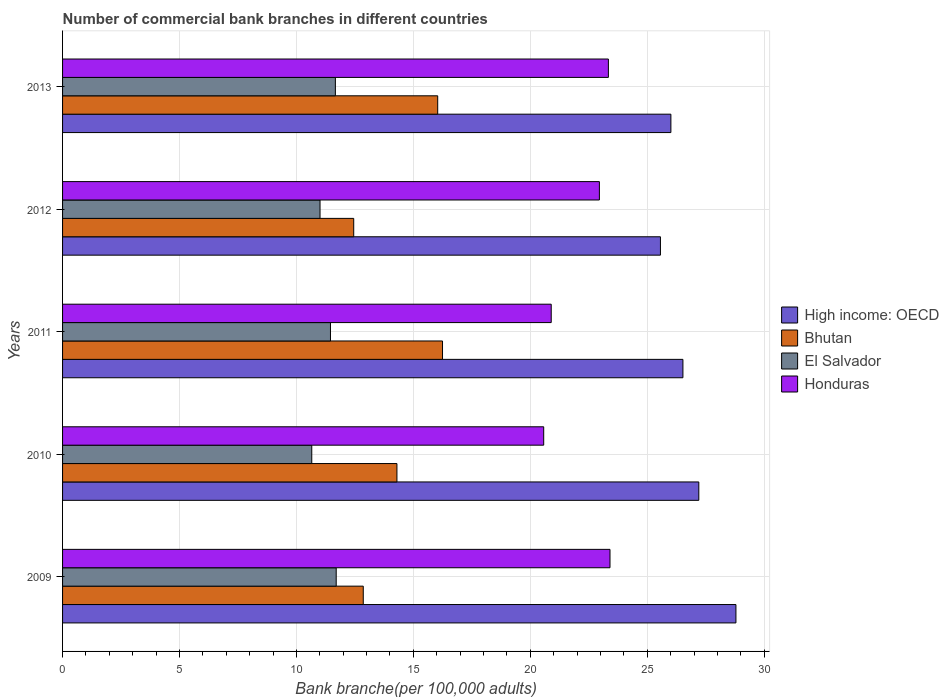How many groups of bars are there?
Your answer should be compact. 5. Are the number of bars on each tick of the Y-axis equal?
Keep it short and to the point. Yes. How many bars are there on the 1st tick from the bottom?
Give a very brief answer. 4. What is the number of commercial bank branches in Honduras in 2009?
Provide a short and direct response. 23.41. Across all years, what is the maximum number of commercial bank branches in Honduras?
Give a very brief answer. 23.41. Across all years, what is the minimum number of commercial bank branches in El Salvador?
Provide a short and direct response. 10.66. In which year was the number of commercial bank branches in El Salvador maximum?
Keep it short and to the point. 2009. In which year was the number of commercial bank branches in Bhutan minimum?
Provide a succinct answer. 2012. What is the total number of commercial bank branches in Honduras in the graph?
Provide a succinct answer. 111.17. What is the difference between the number of commercial bank branches in Bhutan in 2009 and that in 2013?
Give a very brief answer. -3.18. What is the difference between the number of commercial bank branches in El Salvador in 2010 and the number of commercial bank branches in Bhutan in 2009?
Give a very brief answer. -2.2. What is the average number of commercial bank branches in Honduras per year?
Ensure brevity in your answer.  22.23. In the year 2010, what is the difference between the number of commercial bank branches in Honduras and number of commercial bank branches in High income: OECD?
Ensure brevity in your answer.  -6.63. What is the ratio of the number of commercial bank branches in High income: OECD in 2009 to that in 2012?
Your answer should be compact. 1.13. Is the difference between the number of commercial bank branches in Honduras in 2010 and 2011 greater than the difference between the number of commercial bank branches in High income: OECD in 2010 and 2011?
Your answer should be compact. No. What is the difference between the highest and the second highest number of commercial bank branches in Honduras?
Give a very brief answer. 0.07. What is the difference between the highest and the lowest number of commercial bank branches in High income: OECD?
Make the answer very short. 3.23. In how many years, is the number of commercial bank branches in High income: OECD greater than the average number of commercial bank branches in High income: OECD taken over all years?
Ensure brevity in your answer.  2. Is it the case that in every year, the sum of the number of commercial bank branches in High income: OECD and number of commercial bank branches in Honduras is greater than the sum of number of commercial bank branches in Bhutan and number of commercial bank branches in El Salvador?
Make the answer very short. No. What does the 4th bar from the top in 2013 represents?
Offer a terse response. High income: OECD. What does the 4th bar from the bottom in 2010 represents?
Make the answer very short. Honduras. Is it the case that in every year, the sum of the number of commercial bank branches in Bhutan and number of commercial bank branches in Honduras is greater than the number of commercial bank branches in High income: OECD?
Offer a very short reply. Yes. How many bars are there?
Make the answer very short. 20. Are all the bars in the graph horizontal?
Offer a terse response. Yes. How many years are there in the graph?
Give a very brief answer. 5. What is the difference between two consecutive major ticks on the X-axis?
Ensure brevity in your answer.  5. Does the graph contain grids?
Keep it short and to the point. Yes. How many legend labels are there?
Your answer should be very brief. 4. What is the title of the graph?
Provide a short and direct response. Number of commercial bank branches in different countries. What is the label or title of the X-axis?
Your answer should be very brief. Bank branche(per 100,0 adults). What is the label or title of the Y-axis?
Your answer should be compact. Years. What is the Bank branche(per 100,000 adults) of High income: OECD in 2009?
Provide a succinct answer. 28.79. What is the Bank branche(per 100,000 adults) of Bhutan in 2009?
Provide a short and direct response. 12.86. What is the Bank branche(per 100,000 adults) of El Salvador in 2009?
Make the answer very short. 11.7. What is the Bank branche(per 100,000 adults) in Honduras in 2009?
Your response must be concise. 23.41. What is the Bank branche(per 100,000 adults) in High income: OECD in 2010?
Offer a terse response. 27.21. What is the Bank branche(per 100,000 adults) of Bhutan in 2010?
Your answer should be compact. 14.3. What is the Bank branche(per 100,000 adults) of El Salvador in 2010?
Offer a very short reply. 10.66. What is the Bank branche(per 100,000 adults) of Honduras in 2010?
Offer a very short reply. 20.57. What is the Bank branche(per 100,000 adults) in High income: OECD in 2011?
Your answer should be very brief. 26.53. What is the Bank branche(per 100,000 adults) of Bhutan in 2011?
Ensure brevity in your answer.  16.25. What is the Bank branche(per 100,000 adults) in El Salvador in 2011?
Provide a short and direct response. 11.46. What is the Bank branche(per 100,000 adults) in Honduras in 2011?
Provide a short and direct response. 20.89. What is the Bank branche(per 100,000 adults) in High income: OECD in 2012?
Provide a succinct answer. 25.56. What is the Bank branche(per 100,000 adults) of Bhutan in 2012?
Offer a terse response. 12.45. What is the Bank branche(per 100,000 adults) of El Salvador in 2012?
Offer a terse response. 11.01. What is the Bank branche(per 100,000 adults) in Honduras in 2012?
Provide a short and direct response. 22.95. What is the Bank branche(per 100,000 adults) in High income: OECD in 2013?
Offer a terse response. 26.01. What is the Bank branche(per 100,000 adults) in Bhutan in 2013?
Your answer should be very brief. 16.04. What is the Bank branche(per 100,000 adults) in El Salvador in 2013?
Give a very brief answer. 11.67. What is the Bank branche(per 100,000 adults) of Honduras in 2013?
Your answer should be very brief. 23.34. Across all years, what is the maximum Bank branche(per 100,000 adults) in High income: OECD?
Your answer should be compact. 28.79. Across all years, what is the maximum Bank branche(per 100,000 adults) in Bhutan?
Ensure brevity in your answer.  16.25. Across all years, what is the maximum Bank branche(per 100,000 adults) of El Salvador?
Keep it short and to the point. 11.7. Across all years, what is the maximum Bank branche(per 100,000 adults) of Honduras?
Ensure brevity in your answer.  23.41. Across all years, what is the minimum Bank branche(per 100,000 adults) of High income: OECD?
Keep it short and to the point. 25.56. Across all years, what is the minimum Bank branche(per 100,000 adults) in Bhutan?
Keep it short and to the point. 12.45. Across all years, what is the minimum Bank branche(per 100,000 adults) of El Salvador?
Provide a succinct answer. 10.66. Across all years, what is the minimum Bank branche(per 100,000 adults) in Honduras?
Offer a terse response. 20.57. What is the total Bank branche(per 100,000 adults) in High income: OECD in the graph?
Provide a succinct answer. 134.1. What is the total Bank branche(per 100,000 adults) of Bhutan in the graph?
Offer a terse response. 71.89. What is the total Bank branche(per 100,000 adults) in El Salvador in the graph?
Offer a very short reply. 56.49. What is the total Bank branche(per 100,000 adults) in Honduras in the graph?
Your answer should be compact. 111.17. What is the difference between the Bank branche(per 100,000 adults) of High income: OECD in 2009 and that in 2010?
Offer a terse response. 1.59. What is the difference between the Bank branche(per 100,000 adults) in Bhutan in 2009 and that in 2010?
Your response must be concise. -1.44. What is the difference between the Bank branche(per 100,000 adults) in El Salvador in 2009 and that in 2010?
Give a very brief answer. 1.04. What is the difference between the Bank branche(per 100,000 adults) of Honduras in 2009 and that in 2010?
Make the answer very short. 2.83. What is the difference between the Bank branche(per 100,000 adults) of High income: OECD in 2009 and that in 2011?
Provide a succinct answer. 2.27. What is the difference between the Bank branche(per 100,000 adults) of Bhutan in 2009 and that in 2011?
Offer a very short reply. -3.39. What is the difference between the Bank branche(per 100,000 adults) in El Salvador in 2009 and that in 2011?
Ensure brevity in your answer.  0.25. What is the difference between the Bank branche(per 100,000 adults) in Honduras in 2009 and that in 2011?
Offer a very short reply. 2.51. What is the difference between the Bank branche(per 100,000 adults) in High income: OECD in 2009 and that in 2012?
Keep it short and to the point. 3.23. What is the difference between the Bank branche(per 100,000 adults) in Bhutan in 2009 and that in 2012?
Keep it short and to the point. 0.41. What is the difference between the Bank branche(per 100,000 adults) of El Salvador in 2009 and that in 2012?
Offer a terse response. 0.69. What is the difference between the Bank branche(per 100,000 adults) of Honduras in 2009 and that in 2012?
Provide a succinct answer. 0.45. What is the difference between the Bank branche(per 100,000 adults) of High income: OECD in 2009 and that in 2013?
Offer a very short reply. 2.78. What is the difference between the Bank branche(per 100,000 adults) in Bhutan in 2009 and that in 2013?
Your answer should be very brief. -3.18. What is the difference between the Bank branche(per 100,000 adults) of El Salvador in 2009 and that in 2013?
Provide a succinct answer. 0.04. What is the difference between the Bank branche(per 100,000 adults) of Honduras in 2009 and that in 2013?
Your answer should be very brief. 0.07. What is the difference between the Bank branche(per 100,000 adults) in High income: OECD in 2010 and that in 2011?
Offer a very short reply. 0.68. What is the difference between the Bank branche(per 100,000 adults) in Bhutan in 2010 and that in 2011?
Provide a short and direct response. -1.95. What is the difference between the Bank branche(per 100,000 adults) in El Salvador in 2010 and that in 2011?
Give a very brief answer. -0.8. What is the difference between the Bank branche(per 100,000 adults) of Honduras in 2010 and that in 2011?
Your answer should be very brief. -0.32. What is the difference between the Bank branche(per 100,000 adults) in High income: OECD in 2010 and that in 2012?
Offer a terse response. 1.64. What is the difference between the Bank branche(per 100,000 adults) of Bhutan in 2010 and that in 2012?
Provide a short and direct response. 1.85. What is the difference between the Bank branche(per 100,000 adults) in El Salvador in 2010 and that in 2012?
Ensure brevity in your answer.  -0.35. What is the difference between the Bank branche(per 100,000 adults) in Honduras in 2010 and that in 2012?
Your response must be concise. -2.38. What is the difference between the Bank branche(per 100,000 adults) in High income: OECD in 2010 and that in 2013?
Give a very brief answer. 1.19. What is the difference between the Bank branche(per 100,000 adults) in Bhutan in 2010 and that in 2013?
Offer a very short reply. -1.74. What is the difference between the Bank branche(per 100,000 adults) in El Salvador in 2010 and that in 2013?
Give a very brief answer. -1.01. What is the difference between the Bank branche(per 100,000 adults) in Honduras in 2010 and that in 2013?
Your response must be concise. -2.77. What is the difference between the Bank branche(per 100,000 adults) in High income: OECD in 2011 and that in 2012?
Make the answer very short. 0.96. What is the difference between the Bank branche(per 100,000 adults) in Bhutan in 2011 and that in 2012?
Your answer should be compact. 3.8. What is the difference between the Bank branche(per 100,000 adults) of El Salvador in 2011 and that in 2012?
Your answer should be very brief. 0.45. What is the difference between the Bank branche(per 100,000 adults) in Honduras in 2011 and that in 2012?
Keep it short and to the point. -2.06. What is the difference between the Bank branche(per 100,000 adults) in High income: OECD in 2011 and that in 2013?
Ensure brevity in your answer.  0.51. What is the difference between the Bank branche(per 100,000 adults) in Bhutan in 2011 and that in 2013?
Ensure brevity in your answer.  0.21. What is the difference between the Bank branche(per 100,000 adults) of El Salvador in 2011 and that in 2013?
Offer a terse response. -0.21. What is the difference between the Bank branche(per 100,000 adults) of Honduras in 2011 and that in 2013?
Your response must be concise. -2.44. What is the difference between the Bank branche(per 100,000 adults) in High income: OECD in 2012 and that in 2013?
Offer a terse response. -0.45. What is the difference between the Bank branche(per 100,000 adults) of Bhutan in 2012 and that in 2013?
Ensure brevity in your answer.  -3.59. What is the difference between the Bank branche(per 100,000 adults) of El Salvador in 2012 and that in 2013?
Make the answer very short. -0.66. What is the difference between the Bank branche(per 100,000 adults) of Honduras in 2012 and that in 2013?
Make the answer very short. -0.38. What is the difference between the Bank branche(per 100,000 adults) of High income: OECD in 2009 and the Bank branche(per 100,000 adults) of Bhutan in 2010?
Keep it short and to the point. 14.49. What is the difference between the Bank branche(per 100,000 adults) in High income: OECD in 2009 and the Bank branche(per 100,000 adults) in El Salvador in 2010?
Your response must be concise. 18.14. What is the difference between the Bank branche(per 100,000 adults) in High income: OECD in 2009 and the Bank branche(per 100,000 adults) in Honduras in 2010?
Provide a short and direct response. 8.22. What is the difference between the Bank branche(per 100,000 adults) in Bhutan in 2009 and the Bank branche(per 100,000 adults) in El Salvador in 2010?
Provide a succinct answer. 2.2. What is the difference between the Bank branche(per 100,000 adults) in Bhutan in 2009 and the Bank branche(per 100,000 adults) in Honduras in 2010?
Give a very brief answer. -7.72. What is the difference between the Bank branche(per 100,000 adults) of El Salvador in 2009 and the Bank branche(per 100,000 adults) of Honduras in 2010?
Offer a very short reply. -8.87. What is the difference between the Bank branche(per 100,000 adults) of High income: OECD in 2009 and the Bank branche(per 100,000 adults) of Bhutan in 2011?
Make the answer very short. 12.55. What is the difference between the Bank branche(per 100,000 adults) of High income: OECD in 2009 and the Bank branche(per 100,000 adults) of El Salvador in 2011?
Give a very brief answer. 17.34. What is the difference between the Bank branche(per 100,000 adults) in High income: OECD in 2009 and the Bank branche(per 100,000 adults) in Honduras in 2011?
Your answer should be very brief. 7.9. What is the difference between the Bank branche(per 100,000 adults) in Bhutan in 2009 and the Bank branche(per 100,000 adults) in El Salvador in 2011?
Your response must be concise. 1.4. What is the difference between the Bank branche(per 100,000 adults) in Bhutan in 2009 and the Bank branche(per 100,000 adults) in Honduras in 2011?
Your answer should be compact. -8.04. What is the difference between the Bank branche(per 100,000 adults) in El Salvador in 2009 and the Bank branche(per 100,000 adults) in Honduras in 2011?
Offer a terse response. -9.19. What is the difference between the Bank branche(per 100,000 adults) in High income: OECD in 2009 and the Bank branche(per 100,000 adults) in Bhutan in 2012?
Your answer should be very brief. 16.34. What is the difference between the Bank branche(per 100,000 adults) in High income: OECD in 2009 and the Bank branche(per 100,000 adults) in El Salvador in 2012?
Keep it short and to the point. 17.78. What is the difference between the Bank branche(per 100,000 adults) of High income: OECD in 2009 and the Bank branche(per 100,000 adults) of Honduras in 2012?
Give a very brief answer. 5.84. What is the difference between the Bank branche(per 100,000 adults) of Bhutan in 2009 and the Bank branche(per 100,000 adults) of El Salvador in 2012?
Your answer should be compact. 1.85. What is the difference between the Bank branche(per 100,000 adults) of Bhutan in 2009 and the Bank branche(per 100,000 adults) of Honduras in 2012?
Provide a short and direct response. -10.1. What is the difference between the Bank branche(per 100,000 adults) of El Salvador in 2009 and the Bank branche(per 100,000 adults) of Honduras in 2012?
Provide a short and direct response. -11.25. What is the difference between the Bank branche(per 100,000 adults) of High income: OECD in 2009 and the Bank branche(per 100,000 adults) of Bhutan in 2013?
Your answer should be very brief. 12.75. What is the difference between the Bank branche(per 100,000 adults) of High income: OECD in 2009 and the Bank branche(per 100,000 adults) of El Salvador in 2013?
Your answer should be very brief. 17.13. What is the difference between the Bank branche(per 100,000 adults) of High income: OECD in 2009 and the Bank branche(per 100,000 adults) of Honduras in 2013?
Keep it short and to the point. 5.45. What is the difference between the Bank branche(per 100,000 adults) of Bhutan in 2009 and the Bank branche(per 100,000 adults) of El Salvador in 2013?
Your answer should be compact. 1.19. What is the difference between the Bank branche(per 100,000 adults) in Bhutan in 2009 and the Bank branche(per 100,000 adults) in Honduras in 2013?
Offer a terse response. -10.48. What is the difference between the Bank branche(per 100,000 adults) in El Salvador in 2009 and the Bank branche(per 100,000 adults) in Honduras in 2013?
Ensure brevity in your answer.  -11.64. What is the difference between the Bank branche(per 100,000 adults) in High income: OECD in 2010 and the Bank branche(per 100,000 adults) in Bhutan in 2011?
Make the answer very short. 10.96. What is the difference between the Bank branche(per 100,000 adults) of High income: OECD in 2010 and the Bank branche(per 100,000 adults) of El Salvador in 2011?
Give a very brief answer. 15.75. What is the difference between the Bank branche(per 100,000 adults) in High income: OECD in 2010 and the Bank branche(per 100,000 adults) in Honduras in 2011?
Provide a short and direct response. 6.31. What is the difference between the Bank branche(per 100,000 adults) of Bhutan in 2010 and the Bank branche(per 100,000 adults) of El Salvador in 2011?
Your response must be concise. 2.84. What is the difference between the Bank branche(per 100,000 adults) in Bhutan in 2010 and the Bank branche(per 100,000 adults) in Honduras in 2011?
Ensure brevity in your answer.  -6.6. What is the difference between the Bank branche(per 100,000 adults) of El Salvador in 2010 and the Bank branche(per 100,000 adults) of Honduras in 2011?
Give a very brief answer. -10.24. What is the difference between the Bank branche(per 100,000 adults) in High income: OECD in 2010 and the Bank branche(per 100,000 adults) in Bhutan in 2012?
Your answer should be very brief. 14.76. What is the difference between the Bank branche(per 100,000 adults) of High income: OECD in 2010 and the Bank branche(per 100,000 adults) of El Salvador in 2012?
Offer a very short reply. 16.2. What is the difference between the Bank branche(per 100,000 adults) in High income: OECD in 2010 and the Bank branche(per 100,000 adults) in Honduras in 2012?
Ensure brevity in your answer.  4.25. What is the difference between the Bank branche(per 100,000 adults) in Bhutan in 2010 and the Bank branche(per 100,000 adults) in El Salvador in 2012?
Your answer should be very brief. 3.29. What is the difference between the Bank branche(per 100,000 adults) of Bhutan in 2010 and the Bank branche(per 100,000 adults) of Honduras in 2012?
Make the answer very short. -8.66. What is the difference between the Bank branche(per 100,000 adults) in El Salvador in 2010 and the Bank branche(per 100,000 adults) in Honduras in 2012?
Provide a succinct answer. -12.3. What is the difference between the Bank branche(per 100,000 adults) of High income: OECD in 2010 and the Bank branche(per 100,000 adults) of Bhutan in 2013?
Offer a terse response. 11.16. What is the difference between the Bank branche(per 100,000 adults) in High income: OECD in 2010 and the Bank branche(per 100,000 adults) in El Salvador in 2013?
Offer a terse response. 15.54. What is the difference between the Bank branche(per 100,000 adults) of High income: OECD in 2010 and the Bank branche(per 100,000 adults) of Honduras in 2013?
Make the answer very short. 3.87. What is the difference between the Bank branche(per 100,000 adults) in Bhutan in 2010 and the Bank branche(per 100,000 adults) in El Salvador in 2013?
Keep it short and to the point. 2.63. What is the difference between the Bank branche(per 100,000 adults) of Bhutan in 2010 and the Bank branche(per 100,000 adults) of Honduras in 2013?
Ensure brevity in your answer.  -9.04. What is the difference between the Bank branche(per 100,000 adults) of El Salvador in 2010 and the Bank branche(per 100,000 adults) of Honduras in 2013?
Keep it short and to the point. -12.68. What is the difference between the Bank branche(per 100,000 adults) of High income: OECD in 2011 and the Bank branche(per 100,000 adults) of Bhutan in 2012?
Keep it short and to the point. 14.08. What is the difference between the Bank branche(per 100,000 adults) in High income: OECD in 2011 and the Bank branche(per 100,000 adults) in El Salvador in 2012?
Give a very brief answer. 15.52. What is the difference between the Bank branche(per 100,000 adults) in High income: OECD in 2011 and the Bank branche(per 100,000 adults) in Honduras in 2012?
Provide a short and direct response. 3.57. What is the difference between the Bank branche(per 100,000 adults) in Bhutan in 2011 and the Bank branche(per 100,000 adults) in El Salvador in 2012?
Keep it short and to the point. 5.24. What is the difference between the Bank branche(per 100,000 adults) of Bhutan in 2011 and the Bank branche(per 100,000 adults) of Honduras in 2012?
Offer a very short reply. -6.71. What is the difference between the Bank branche(per 100,000 adults) in El Salvador in 2011 and the Bank branche(per 100,000 adults) in Honduras in 2012?
Your response must be concise. -11.5. What is the difference between the Bank branche(per 100,000 adults) of High income: OECD in 2011 and the Bank branche(per 100,000 adults) of Bhutan in 2013?
Offer a very short reply. 10.49. What is the difference between the Bank branche(per 100,000 adults) in High income: OECD in 2011 and the Bank branche(per 100,000 adults) in El Salvador in 2013?
Your response must be concise. 14.86. What is the difference between the Bank branche(per 100,000 adults) of High income: OECD in 2011 and the Bank branche(per 100,000 adults) of Honduras in 2013?
Make the answer very short. 3.19. What is the difference between the Bank branche(per 100,000 adults) of Bhutan in 2011 and the Bank branche(per 100,000 adults) of El Salvador in 2013?
Keep it short and to the point. 4.58. What is the difference between the Bank branche(per 100,000 adults) of Bhutan in 2011 and the Bank branche(per 100,000 adults) of Honduras in 2013?
Your answer should be compact. -7.09. What is the difference between the Bank branche(per 100,000 adults) in El Salvador in 2011 and the Bank branche(per 100,000 adults) in Honduras in 2013?
Offer a very short reply. -11.88. What is the difference between the Bank branche(per 100,000 adults) of High income: OECD in 2012 and the Bank branche(per 100,000 adults) of Bhutan in 2013?
Your response must be concise. 9.52. What is the difference between the Bank branche(per 100,000 adults) of High income: OECD in 2012 and the Bank branche(per 100,000 adults) of El Salvador in 2013?
Provide a succinct answer. 13.9. What is the difference between the Bank branche(per 100,000 adults) of High income: OECD in 2012 and the Bank branche(per 100,000 adults) of Honduras in 2013?
Ensure brevity in your answer.  2.23. What is the difference between the Bank branche(per 100,000 adults) in Bhutan in 2012 and the Bank branche(per 100,000 adults) in El Salvador in 2013?
Offer a terse response. 0.78. What is the difference between the Bank branche(per 100,000 adults) of Bhutan in 2012 and the Bank branche(per 100,000 adults) of Honduras in 2013?
Offer a very short reply. -10.89. What is the difference between the Bank branche(per 100,000 adults) of El Salvador in 2012 and the Bank branche(per 100,000 adults) of Honduras in 2013?
Give a very brief answer. -12.33. What is the average Bank branche(per 100,000 adults) of High income: OECD per year?
Keep it short and to the point. 26.82. What is the average Bank branche(per 100,000 adults) in Bhutan per year?
Make the answer very short. 14.38. What is the average Bank branche(per 100,000 adults) in El Salvador per year?
Your answer should be compact. 11.3. What is the average Bank branche(per 100,000 adults) in Honduras per year?
Your response must be concise. 22.23. In the year 2009, what is the difference between the Bank branche(per 100,000 adults) of High income: OECD and Bank branche(per 100,000 adults) of Bhutan?
Provide a succinct answer. 15.94. In the year 2009, what is the difference between the Bank branche(per 100,000 adults) of High income: OECD and Bank branche(per 100,000 adults) of El Salvador?
Ensure brevity in your answer.  17.09. In the year 2009, what is the difference between the Bank branche(per 100,000 adults) in High income: OECD and Bank branche(per 100,000 adults) in Honduras?
Offer a very short reply. 5.38. In the year 2009, what is the difference between the Bank branche(per 100,000 adults) in Bhutan and Bank branche(per 100,000 adults) in El Salvador?
Give a very brief answer. 1.16. In the year 2009, what is the difference between the Bank branche(per 100,000 adults) of Bhutan and Bank branche(per 100,000 adults) of Honduras?
Your response must be concise. -10.55. In the year 2009, what is the difference between the Bank branche(per 100,000 adults) in El Salvador and Bank branche(per 100,000 adults) in Honduras?
Keep it short and to the point. -11.71. In the year 2010, what is the difference between the Bank branche(per 100,000 adults) in High income: OECD and Bank branche(per 100,000 adults) in Bhutan?
Your response must be concise. 12.91. In the year 2010, what is the difference between the Bank branche(per 100,000 adults) of High income: OECD and Bank branche(per 100,000 adults) of El Salvador?
Offer a terse response. 16.55. In the year 2010, what is the difference between the Bank branche(per 100,000 adults) in High income: OECD and Bank branche(per 100,000 adults) in Honduras?
Your answer should be compact. 6.63. In the year 2010, what is the difference between the Bank branche(per 100,000 adults) in Bhutan and Bank branche(per 100,000 adults) in El Salvador?
Make the answer very short. 3.64. In the year 2010, what is the difference between the Bank branche(per 100,000 adults) of Bhutan and Bank branche(per 100,000 adults) of Honduras?
Make the answer very short. -6.28. In the year 2010, what is the difference between the Bank branche(per 100,000 adults) of El Salvador and Bank branche(per 100,000 adults) of Honduras?
Your response must be concise. -9.92. In the year 2011, what is the difference between the Bank branche(per 100,000 adults) in High income: OECD and Bank branche(per 100,000 adults) in Bhutan?
Give a very brief answer. 10.28. In the year 2011, what is the difference between the Bank branche(per 100,000 adults) in High income: OECD and Bank branche(per 100,000 adults) in El Salvador?
Your answer should be very brief. 15.07. In the year 2011, what is the difference between the Bank branche(per 100,000 adults) in High income: OECD and Bank branche(per 100,000 adults) in Honduras?
Give a very brief answer. 5.63. In the year 2011, what is the difference between the Bank branche(per 100,000 adults) of Bhutan and Bank branche(per 100,000 adults) of El Salvador?
Provide a succinct answer. 4.79. In the year 2011, what is the difference between the Bank branche(per 100,000 adults) in Bhutan and Bank branche(per 100,000 adults) in Honduras?
Keep it short and to the point. -4.65. In the year 2011, what is the difference between the Bank branche(per 100,000 adults) of El Salvador and Bank branche(per 100,000 adults) of Honduras?
Your answer should be compact. -9.44. In the year 2012, what is the difference between the Bank branche(per 100,000 adults) in High income: OECD and Bank branche(per 100,000 adults) in Bhutan?
Your response must be concise. 13.12. In the year 2012, what is the difference between the Bank branche(per 100,000 adults) in High income: OECD and Bank branche(per 100,000 adults) in El Salvador?
Make the answer very short. 14.56. In the year 2012, what is the difference between the Bank branche(per 100,000 adults) in High income: OECD and Bank branche(per 100,000 adults) in Honduras?
Give a very brief answer. 2.61. In the year 2012, what is the difference between the Bank branche(per 100,000 adults) in Bhutan and Bank branche(per 100,000 adults) in El Salvador?
Give a very brief answer. 1.44. In the year 2012, what is the difference between the Bank branche(per 100,000 adults) in Bhutan and Bank branche(per 100,000 adults) in Honduras?
Offer a terse response. -10.51. In the year 2012, what is the difference between the Bank branche(per 100,000 adults) in El Salvador and Bank branche(per 100,000 adults) in Honduras?
Offer a very short reply. -11.95. In the year 2013, what is the difference between the Bank branche(per 100,000 adults) of High income: OECD and Bank branche(per 100,000 adults) of Bhutan?
Keep it short and to the point. 9.97. In the year 2013, what is the difference between the Bank branche(per 100,000 adults) of High income: OECD and Bank branche(per 100,000 adults) of El Salvador?
Give a very brief answer. 14.35. In the year 2013, what is the difference between the Bank branche(per 100,000 adults) of High income: OECD and Bank branche(per 100,000 adults) of Honduras?
Your answer should be compact. 2.67. In the year 2013, what is the difference between the Bank branche(per 100,000 adults) of Bhutan and Bank branche(per 100,000 adults) of El Salvador?
Your answer should be compact. 4.38. In the year 2013, what is the difference between the Bank branche(per 100,000 adults) of Bhutan and Bank branche(per 100,000 adults) of Honduras?
Ensure brevity in your answer.  -7.3. In the year 2013, what is the difference between the Bank branche(per 100,000 adults) of El Salvador and Bank branche(per 100,000 adults) of Honduras?
Offer a terse response. -11.67. What is the ratio of the Bank branche(per 100,000 adults) of High income: OECD in 2009 to that in 2010?
Ensure brevity in your answer.  1.06. What is the ratio of the Bank branche(per 100,000 adults) of Bhutan in 2009 to that in 2010?
Your answer should be very brief. 0.9. What is the ratio of the Bank branche(per 100,000 adults) of El Salvador in 2009 to that in 2010?
Keep it short and to the point. 1.1. What is the ratio of the Bank branche(per 100,000 adults) of Honduras in 2009 to that in 2010?
Your answer should be very brief. 1.14. What is the ratio of the Bank branche(per 100,000 adults) of High income: OECD in 2009 to that in 2011?
Give a very brief answer. 1.09. What is the ratio of the Bank branche(per 100,000 adults) of Bhutan in 2009 to that in 2011?
Your answer should be compact. 0.79. What is the ratio of the Bank branche(per 100,000 adults) in El Salvador in 2009 to that in 2011?
Provide a short and direct response. 1.02. What is the ratio of the Bank branche(per 100,000 adults) in Honduras in 2009 to that in 2011?
Offer a very short reply. 1.12. What is the ratio of the Bank branche(per 100,000 adults) of High income: OECD in 2009 to that in 2012?
Your answer should be very brief. 1.13. What is the ratio of the Bank branche(per 100,000 adults) in Bhutan in 2009 to that in 2012?
Your response must be concise. 1.03. What is the ratio of the Bank branche(per 100,000 adults) in El Salvador in 2009 to that in 2012?
Ensure brevity in your answer.  1.06. What is the ratio of the Bank branche(per 100,000 adults) in Honduras in 2009 to that in 2012?
Offer a very short reply. 1.02. What is the ratio of the Bank branche(per 100,000 adults) in High income: OECD in 2009 to that in 2013?
Keep it short and to the point. 1.11. What is the ratio of the Bank branche(per 100,000 adults) of Bhutan in 2009 to that in 2013?
Your answer should be very brief. 0.8. What is the ratio of the Bank branche(per 100,000 adults) in High income: OECD in 2010 to that in 2011?
Keep it short and to the point. 1.03. What is the ratio of the Bank branche(per 100,000 adults) in El Salvador in 2010 to that in 2011?
Give a very brief answer. 0.93. What is the ratio of the Bank branche(per 100,000 adults) of Honduras in 2010 to that in 2011?
Make the answer very short. 0.98. What is the ratio of the Bank branche(per 100,000 adults) of High income: OECD in 2010 to that in 2012?
Keep it short and to the point. 1.06. What is the ratio of the Bank branche(per 100,000 adults) in Bhutan in 2010 to that in 2012?
Your answer should be compact. 1.15. What is the ratio of the Bank branche(per 100,000 adults) of El Salvador in 2010 to that in 2012?
Ensure brevity in your answer.  0.97. What is the ratio of the Bank branche(per 100,000 adults) in Honduras in 2010 to that in 2012?
Provide a short and direct response. 0.9. What is the ratio of the Bank branche(per 100,000 adults) in High income: OECD in 2010 to that in 2013?
Ensure brevity in your answer.  1.05. What is the ratio of the Bank branche(per 100,000 adults) in Bhutan in 2010 to that in 2013?
Your answer should be compact. 0.89. What is the ratio of the Bank branche(per 100,000 adults) in El Salvador in 2010 to that in 2013?
Ensure brevity in your answer.  0.91. What is the ratio of the Bank branche(per 100,000 adults) of Honduras in 2010 to that in 2013?
Your response must be concise. 0.88. What is the ratio of the Bank branche(per 100,000 adults) in High income: OECD in 2011 to that in 2012?
Your answer should be compact. 1.04. What is the ratio of the Bank branche(per 100,000 adults) of Bhutan in 2011 to that in 2012?
Give a very brief answer. 1.3. What is the ratio of the Bank branche(per 100,000 adults) in El Salvador in 2011 to that in 2012?
Provide a succinct answer. 1.04. What is the ratio of the Bank branche(per 100,000 adults) in Honduras in 2011 to that in 2012?
Your response must be concise. 0.91. What is the ratio of the Bank branche(per 100,000 adults) in High income: OECD in 2011 to that in 2013?
Your answer should be very brief. 1.02. What is the ratio of the Bank branche(per 100,000 adults) of Bhutan in 2011 to that in 2013?
Provide a succinct answer. 1.01. What is the ratio of the Bank branche(per 100,000 adults) in Honduras in 2011 to that in 2013?
Your response must be concise. 0.9. What is the ratio of the Bank branche(per 100,000 adults) in High income: OECD in 2012 to that in 2013?
Ensure brevity in your answer.  0.98. What is the ratio of the Bank branche(per 100,000 adults) in Bhutan in 2012 to that in 2013?
Offer a terse response. 0.78. What is the ratio of the Bank branche(per 100,000 adults) of El Salvador in 2012 to that in 2013?
Offer a very short reply. 0.94. What is the ratio of the Bank branche(per 100,000 adults) in Honduras in 2012 to that in 2013?
Your answer should be compact. 0.98. What is the difference between the highest and the second highest Bank branche(per 100,000 adults) in High income: OECD?
Your answer should be very brief. 1.59. What is the difference between the highest and the second highest Bank branche(per 100,000 adults) in Bhutan?
Give a very brief answer. 0.21. What is the difference between the highest and the second highest Bank branche(per 100,000 adults) in El Salvador?
Your answer should be compact. 0.04. What is the difference between the highest and the second highest Bank branche(per 100,000 adults) in Honduras?
Ensure brevity in your answer.  0.07. What is the difference between the highest and the lowest Bank branche(per 100,000 adults) in High income: OECD?
Your answer should be compact. 3.23. What is the difference between the highest and the lowest Bank branche(per 100,000 adults) of Bhutan?
Keep it short and to the point. 3.8. What is the difference between the highest and the lowest Bank branche(per 100,000 adults) of El Salvador?
Keep it short and to the point. 1.04. What is the difference between the highest and the lowest Bank branche(per 100,000 adults) in Honduras?
Ensure brevity in your answer.  2.83. 